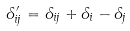<formula> <loc_0><loc_0><loc_500><loc_500>\Lambda _ { i j } ^ { \prime } = \Lambda _ { i j } + \Lambda _ { i } - \Lambda _ { j }</formula> 